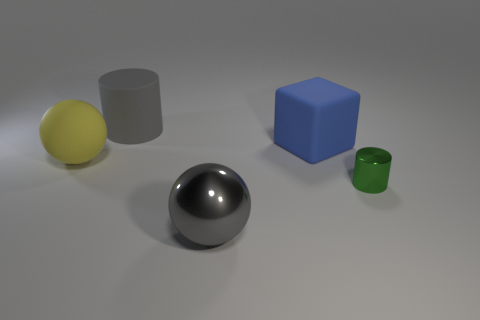Add 1 metal cylinders. How many objects exist? 6 Subtract all balls. How many objects are left? 3 Subtract 0 brown cylinders. How many objects are left? 5 Subtract all big yellow spheres. Subtract all large gray matte cylinders. How many objects are left? 3 Add 4 big gray shiny spheres. How many big gray shiny spheres are left? 5 Add 5 shiny cylinders. How many shiny cylinders exist? 6 